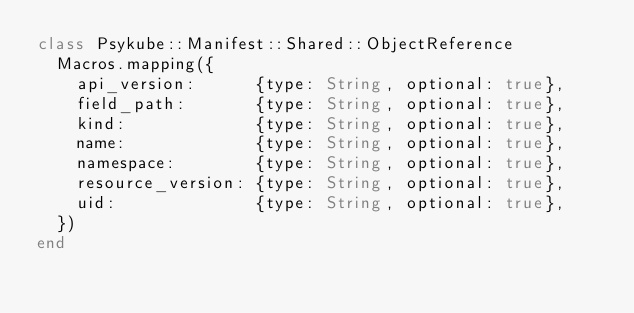Convert code to text. <code><loc_0><loc_0><loc_500><loc_500><_Crystal_>class Psykube::Manifest::Shared::ObjectReference
  Macros.mapping({
    api_version:      {type: String, optional: true},
    field_path:       {type: String, optional: true},
    kind:             {type: String, optional: true},
    name:             {type: String, optional: true},
    namespace:        {type: String, optional: true},
    resource_version: {type: String, optional: true},
    uid:              {type: String, optional: true},
  })
end
</code> 